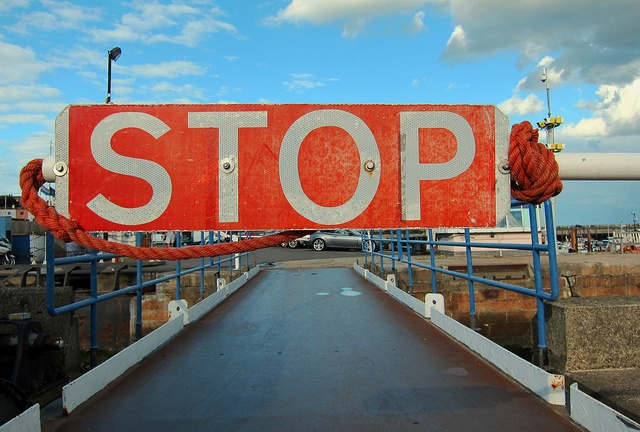Describe the objects in this image and their specific colors. I can see stop sign in lightblue, darkgray, brown, and red tones, car in lightblue, black, gray, darkgray, and blue tones, motorcycle in lightblue, black, gray, and darkgray tones, car in lightblue, blue, black, darkgray, and beige tones, and car in lightblue, black, gray, darkgray, and tan tones in this image. 